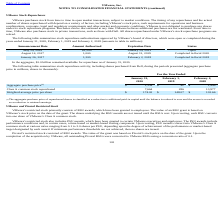According to Vmware's financial document, What was the aggregate purchase price classified as? a reduction to additional paid-in capital until the balance is reduced to zero and the excess is recorded as a reduction to retained earnings.. The document states: "chase price of repurchased shares is classified as a reduction to additional paid-in capital until the balance is reduced to zero and the excess is re..." Also, What was the Class A common stock repurchased in 2019? According to the financial document, 286 (in thousands). The relevant text states: "Class A common stock repurchased 7,664 286 13,977..." Also, What was the Weighted-average price per share in 2018? According to the financial document, 103.66. The relevant text states: "ghted-average price per share $ 174.02 $ 148.07 $ 103.66..." Also, How many years did Class A common stock repurchased exceed $10,000 million? Based on the analysis, there are 1 instances. The counting process: 2018. Also, can you calculate: What was the change in Aggregate purchase price between 2018 and 2019? Based on the calculation: 42-1,449, the result is -1407 (in millions). This is based on the information: "Aggregate purchase price (1) $ 1,334 $ 42 $ 1,449 Aggregate purchase price (1) $ 1,334 $ 42 $ 1,449..." The key data points involved are: 1,449, 42. Also, can you calculate: What was the percentage change in weighted-average price per share between 2019 and 2020? To answer this question, I need to perform calculations using the financial data. The calculation is: (174.02-148.07)/148.07, which equals 17.53 (percentage). This is based on the information: "Weighted-average price per share $ 174.02 $ 148.07 $ 103.66 Weighted-average price per share $ 174.02 $ 148.07 $ 103.66..." The key data points involved are: 148.07, 174.02. 